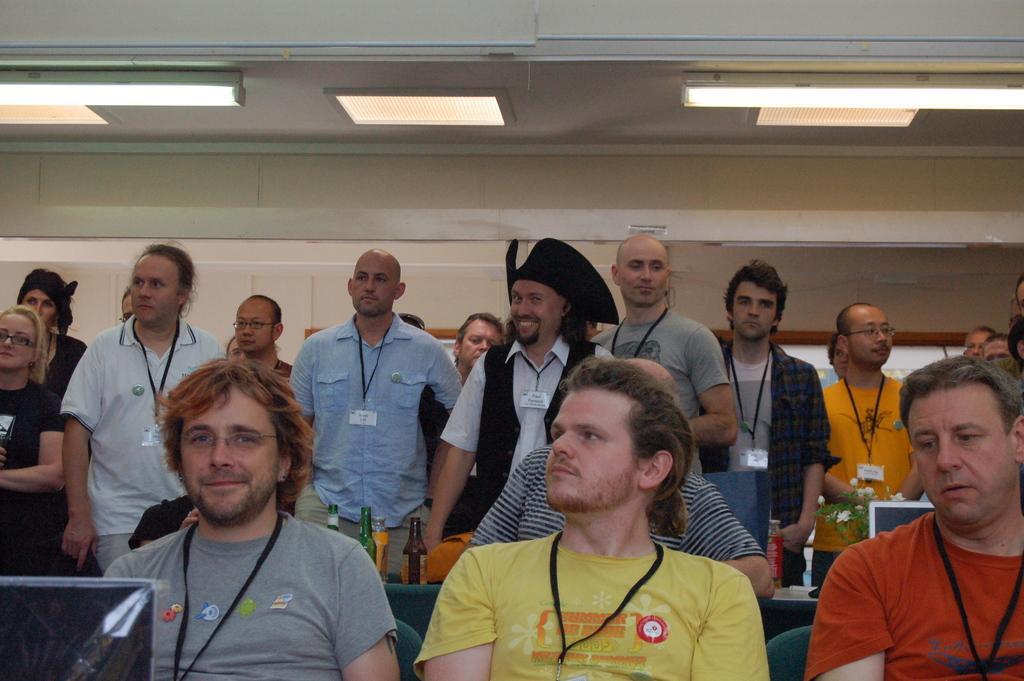Can you describe this image briefly? In this image we can see few people standing and few people sitting in a room, there are few bottles, plant, system on the table and lights to the ceiling. 